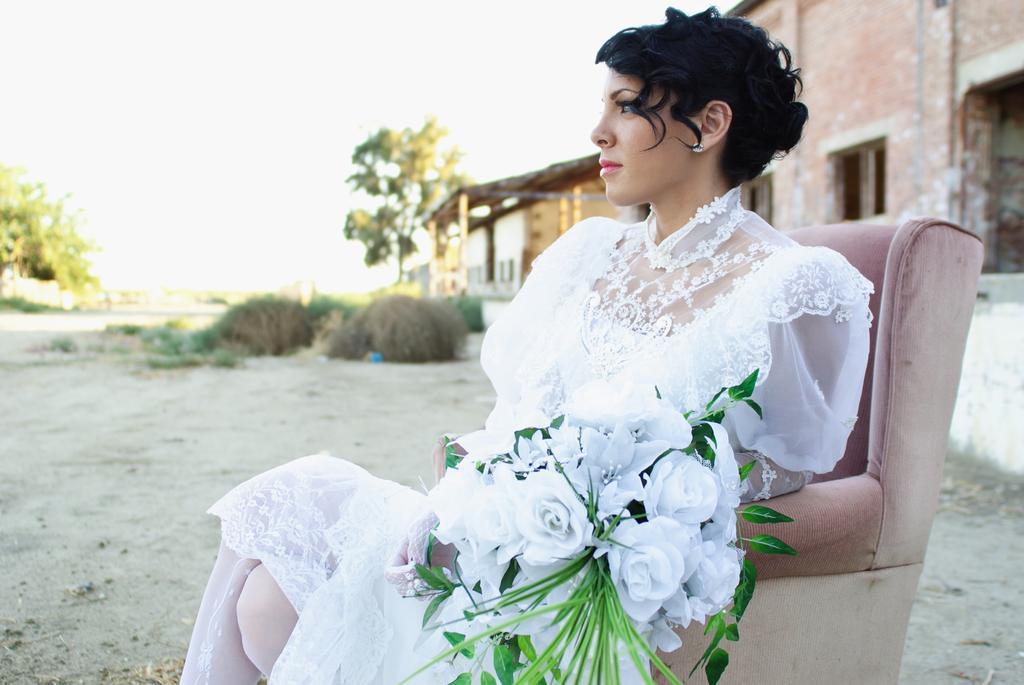In one or two sentences, can you explain what this image depicts? In this image we can see a woman wearing a dress and holding flowers is sitting in a chair placed on the ground. In the background, we can see building with windows shed, group of trees and the sky. 